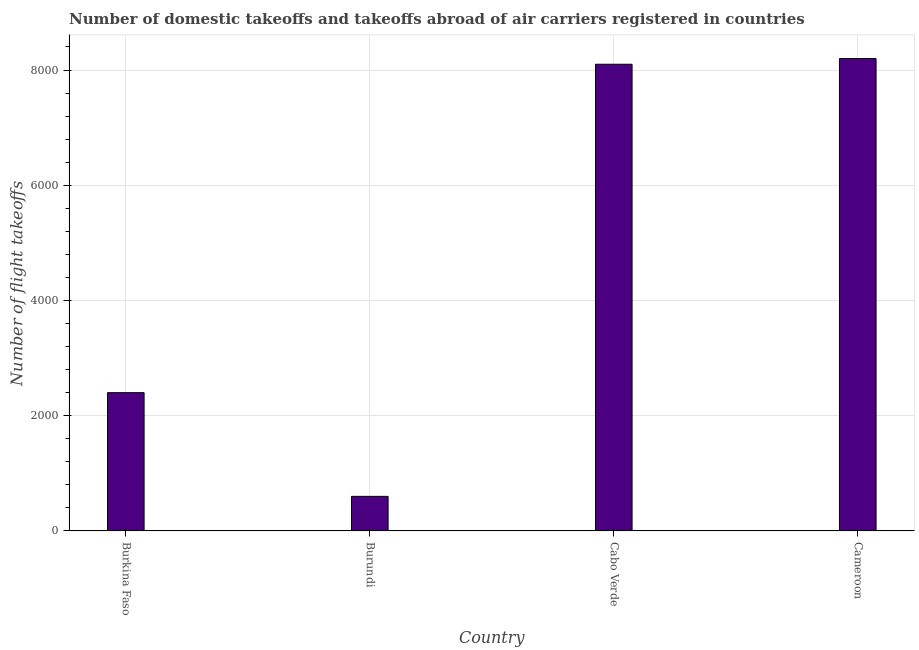What is the title of the graph?
Your answer should be compact. Number of domestic takeoffs and takeoffs abroad of air carriers registered in countries. What is the label or title of the Y-axis?
Make the answer very short. Number of flight takeoffs. What is the number of flight takeoffs in Burkina Faso?
Your answer should be very brief. 2400. Across all countries, what is the maximum number of flight takeoffs?
Your answer should be very brief. 8200. Across all countries, what is the minimum number of flight takeoffs?
Make the answer very short. 600. In which country was the number of flight takeoffs maximum?
Give a very brief answer. Cameroon. In which country was the number of flight takeoffs minimum?
Offer a terse response. Burundi. What is the sum of the number of flight takeoffs?
Keep it short and to the point. 1.93e+04. What is the difference between the number of flight takeoffs in Burkina Faso and Cameroon?
Keep it short and to the point. -5800. What is the average number of flight takeoffs per country?
Your answer should be compact. 4825. What is the median number of flight takeoffs?
Offer a terse response. 5250. In how many countries, is the number of flight takeoffs greater than 1200 ?
Provide a succinct answer. 3. What is the ratio of the number of flight takeoffs in Burundi to that in Cameroon?
Make the answer very short. 0.07. Is the number of flight takeoffs in Burundi less than that in Cameroon?
Provide a succinct answer. Yes. Is the sum of the number of flight takeoffs in Cabo Verde and Cameroon greater than the maximum number of flight takeoffs across all countries?
Your answer should be very brief. Yes. What is the difference between the highest and the lowest number of flight takeoffs?
Offer a terse response. 7600. How many bars are there?
Your answer should be compact. 4. Are all the bars in the graph horizontal?
Keep it short and to the point. No. How many countries are there in the graph?
Your answer should be very brief. 4. What is the difference between two consecutive major ticks on the Y-axis?
Your answer should be compact. 2000. What is the Number of flight takeoffs in Burkina Faso?
Your answer should be very brief. 2400. What is the Number of flight takeoffs in Burundi?
Ensure brevity in your answer.  600. What is the Number of flight takeoffs of Cabo Verde?
Keep it short and to the point. 8100. What is the Number of flight takeoffs in Cameroon?
Make the answer very short. 8200. What is the difference between the Number of flight takeoffs in Burkina Faso and Burundi?
Provide a succinct answer. 1800. What is the difference between the Number of flight takeoffs in Burkina Faso and Cabo Verde?
Provide a succinct answer. -5700. What is the difference between the Number of flight takeoffs in Burkina Faso and Cameroon?
Offer a terse response. -5800. What is the difference between the Number of flight takeoffs in Burundi and Cabo Verde?
Ensure brevity in your answer.  -7500. What is the difference between the Number of flight takeoffs in Burundi and Cameroon?
Keep it short and to the point. -7600. What is the difference between the Number of flight takeoffs in Cabo Verde and Cameroon?
Keep it short and to the point. -100. What is the ratio of the Number of flight takeoffs in Burkina Faso to that in Cabo Verde?
Your response must be concise. 0.3. What is the ratio of the Number of flight takeoffs in Burkina Faso to that in Cameroon?
Make the answer very short. 0.29. What is the ratio of the Number of flight takeoffs in Burundi to that in Cabo Verde?
Make the answer very short. 0.07. What is the ratio of the Number of flight takeoffs in Burundi to that in Cameroon?
Provide a short and direct response. 0.07. What is the ratio of the Number of flight takeoffs in Cabo Verde to that in Cameroon?
Keep it short and to the point. 0.99. 